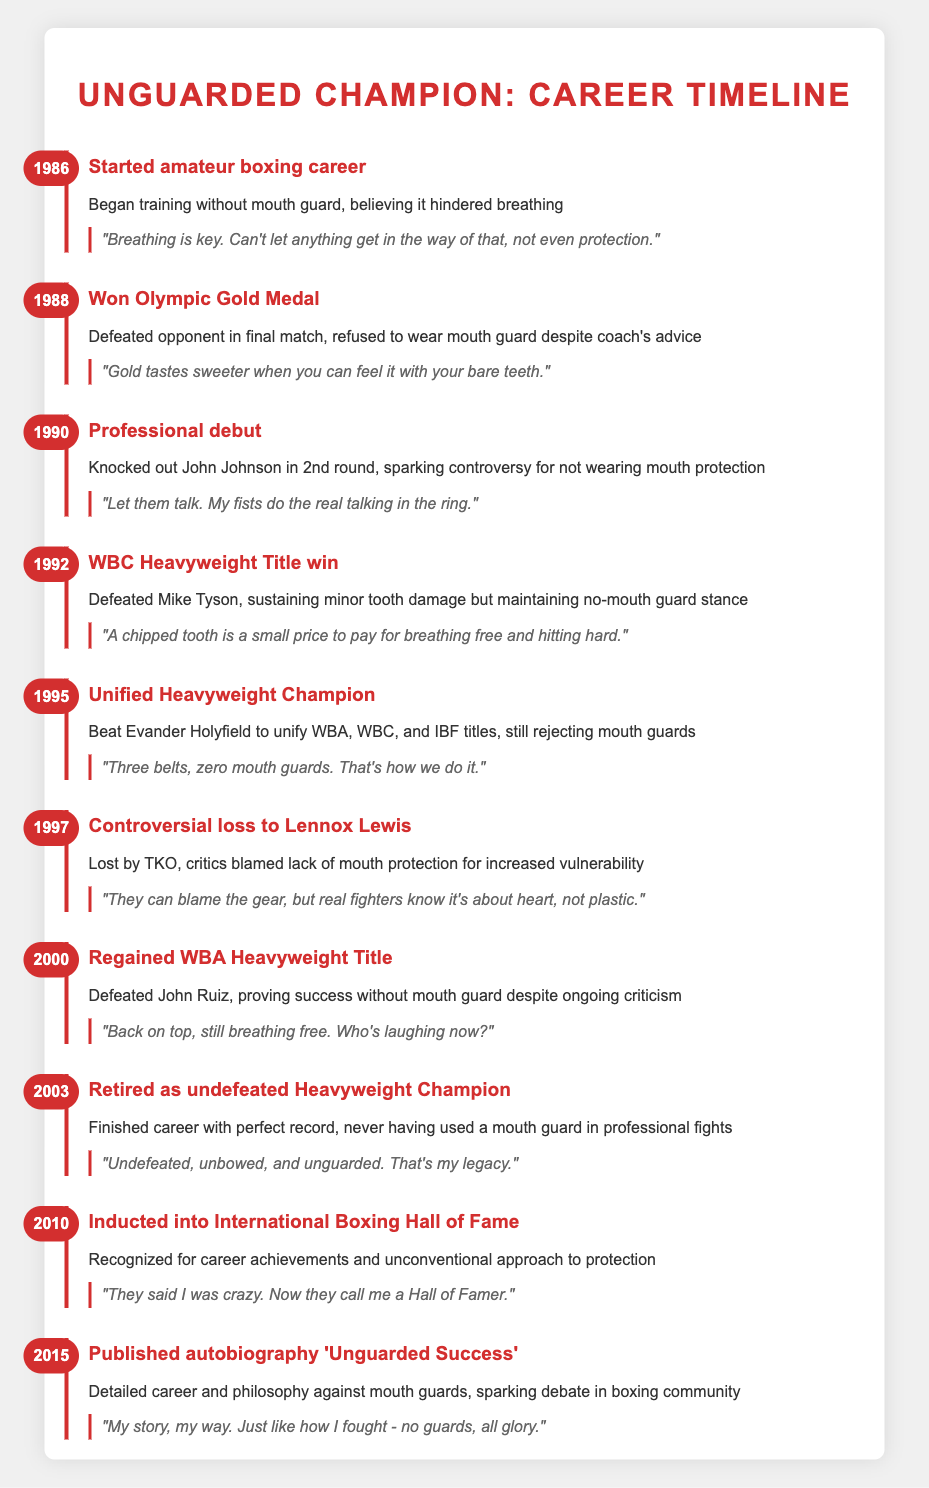What year did the boxer start their amateur boxing career? The table lists several events, with the first event dated 1986. This event states that the boxer started their amateur boxing career.
Answer: 1986 What event occurred in 1995? Looking at the timeline, the event in 1995 is "Unified Heavyweight Champion," detailing that the boxer beat Evander Holyfield to unify the titles.
Answer: Unified Heavyweight Champion Did the boxer wear a mouth guard during their professional debut? The timeline for the professional debut in 1990 indicates that the boxer knocked out John Johnson while sparking controversy for not wearing mouth protection. This implies they did not wear one.
Answer: No How many years passed between winning the Olympic Gold Medal and regaining the WBA Heavyweight Title? The boxer won the Olympic Gold Medal in 1988 and regained the WBA Heavyweight Title in 2000. The difference in years is 2000 - 1988 = 12 years.
Answer: 12 years Was the boxer ever inducted into the International Boxing Hall of Fame? The timeline states that in 2010, the boxer was inducted into the International Boxing Hall of Fame, confirming this fact.
Answer: Yes In what year did the boxer retire as an undefeated Heavyweight Champion? The timeline specifies that the boxer retired as an undefeated Heavyweight Champion in 2003, marking the end of their career.
Answer: 2003 What is the overall trend regarding the use of mouth guards throughout the boxer's career? The timeline consistently shows that the boxer rejected the use of mouth guards throughout their career, from the amateur days until retirement, highlighting a clear trend against their usage.
Answer: No usage of mouth guards How many major events were listed between the years 1990 and 2000? The events between 1990 and 2000 include: Professional debut (1990), WBC Heavyweight Title win (1992), Unified Heavyweight Champion (1995), and Regained WBA Heavyweight Title (2000). This totals to four events.
Answer: 4 events What event has been described as controversial, and which year did it occur? The event described as controversial is the loss to Lennox Lewis, which occurred in 1997, showcasing criticism regarding the lack of mouth protection.
Answer: Controversial loss to Lennox Lewis, 1997 